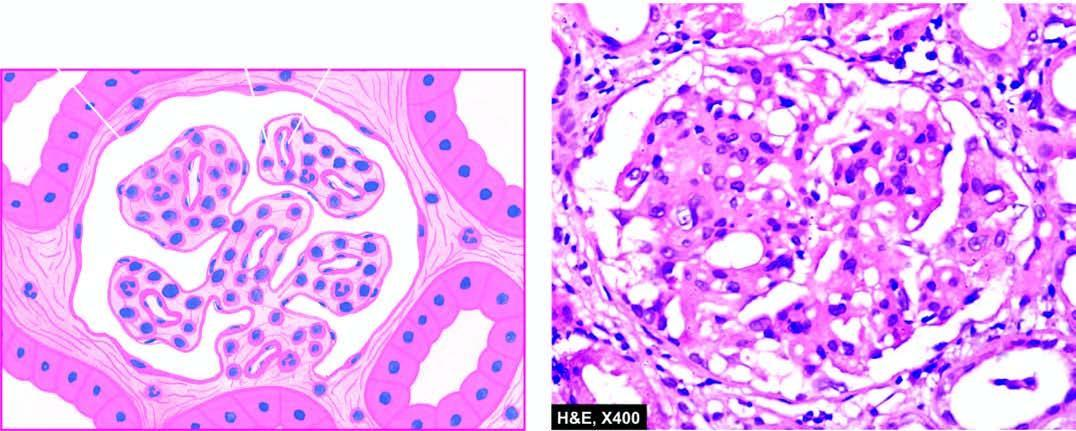do the glomerular tufts show lobulation and mesangial hypercellularity?
Answer the question using a single word or phrase. Yes 